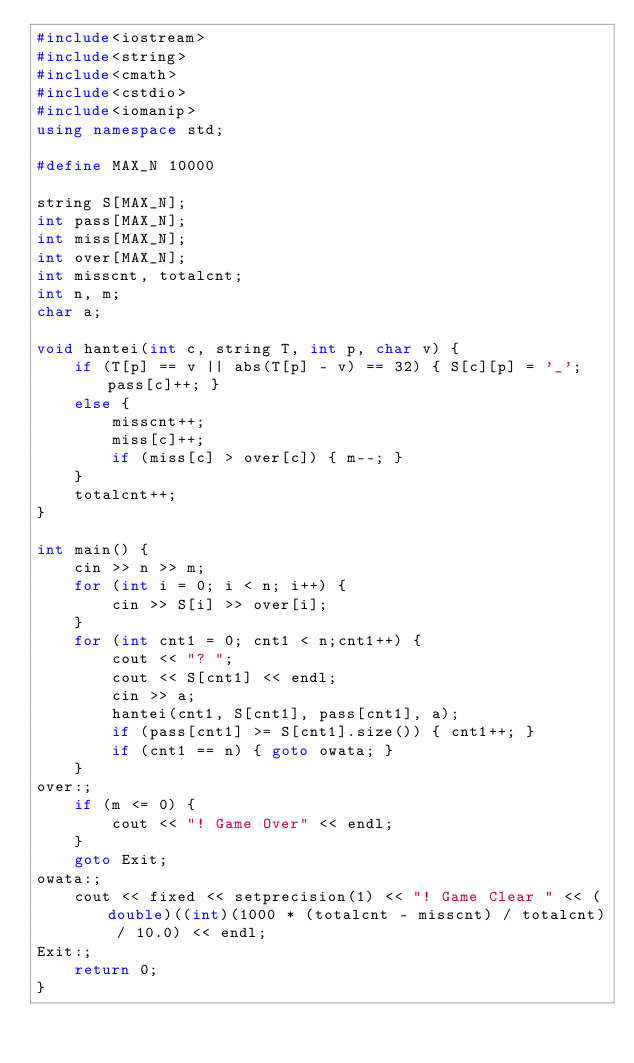<code> <loc_0><loc_0><loc_500><loc_500><_C++_>#include<iostream>
#include<string>
#include<cmath>
#include<cstdio>
#include<iomanip>
using namespace std;

#define MAX_N 10000

string S[MAX_N];
int pass[MAX_N];
int miss[MAX_N];
int over[MAX_N];
int misscnt, totalcnt;
int n, m;
char a;

void hantei(int c, string T, int p, char v) {
	if (T[p] == v || abs(T[p] - v) == 32) { S[c][p] = '_'; pass[c]++; }
	else {
		misscnt++;
		miss[c]++;
		if (miss[c] > over[c]) { m--; }
	}
	totalcnt++;
}

int main() {
	cin >> n >> m;
	for (int i = 0; i < n; i++) {
		cin >> S[i] >> over[i];
	}
	for (int cnt1 = 0; cnt1 < n;cnt1++) {
		cout << "? ";
		cout << S[cnt1] << endl;
		cin >> a;
		hantei(cnt1, S[cnt1], pass[cnt1], a);
		if (pass[cnt1] >= S[cnt1].size()) { cnt1++; }
		if (cnt1 == n) { goto owata; }
	}
over:;
	if (m <= 0) {
		cout << "! Game Over" << endl;
	}
	goto Exit;
owata:;
	cout << fixed << setprecision(1) << "! Game Clear " << (double)((int)(1000 * (totalcnt - misscnt) / totalcnt) / 10.0) << endl;
Exit:;
	return 0;
}</code> 